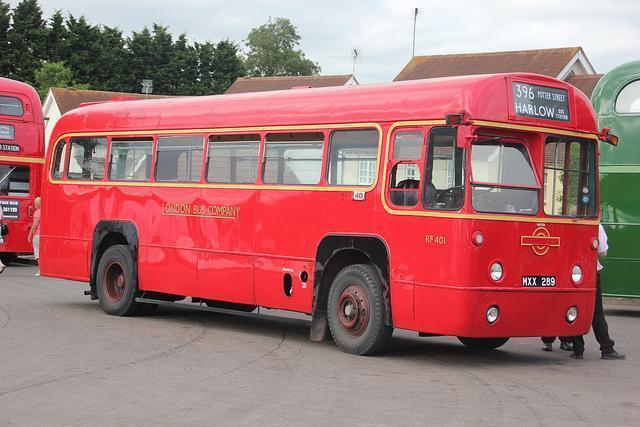How many buses are in the photo?
Give a very brief answer. 3. How many zebras are behind the giraffes?
Give a very brief answer. 0. 